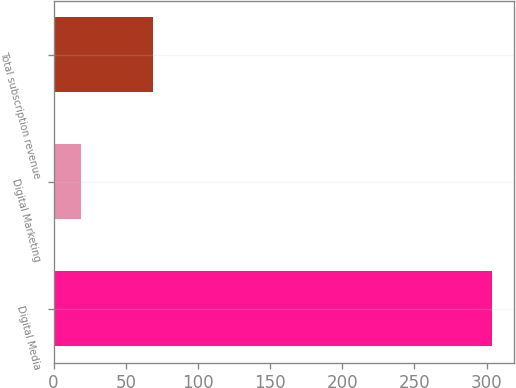Convert chart to OTSL. <chart><loc_0><loc_0><loc_500><loc_500><bar_chart><fcel>Digital Media<fcel>Digital Marketing<fcel>Total subscription revenue<nl><fcel>304<fcel>19<fcel>69<nl></chart> 